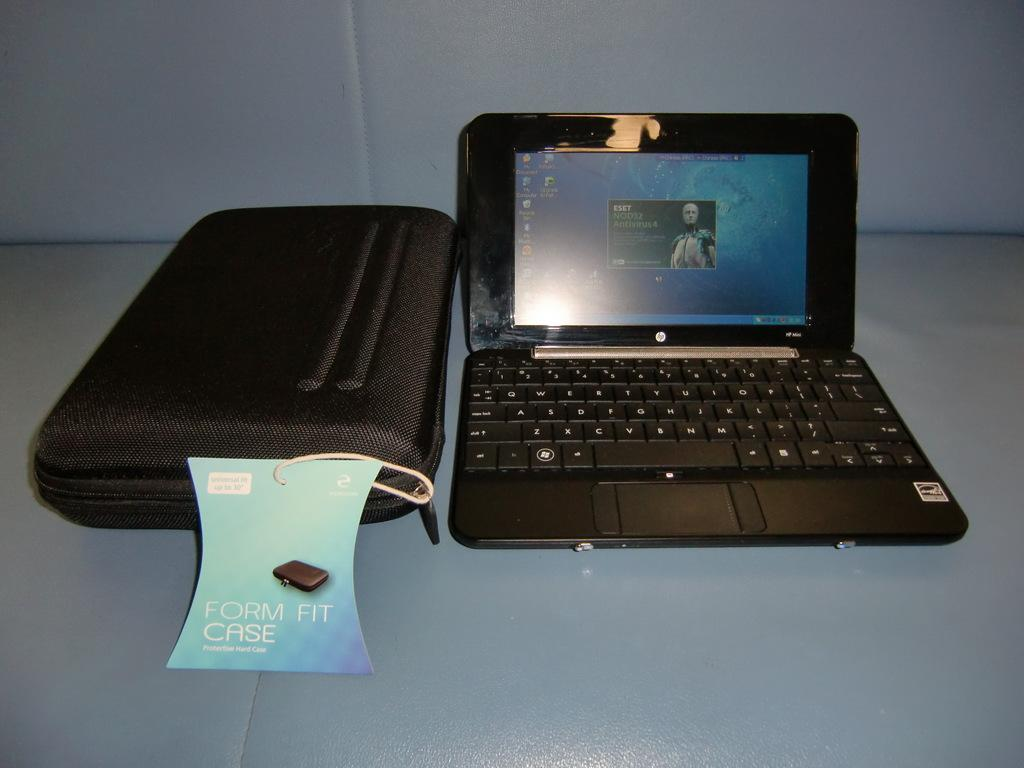What electronic device is visible in the image? There is a laptop in the image. What is placed next to the laptop? There is a case in the image. Where are the laptop and case located? Both the laptop and the case are placed on a surface. What type of tramp is visible in the image? There is no tramp present in the image. How does the society depicted in the image interact with the laptop and case? There is no society depicted in the image, as it only shows a laptop and a case placed on a surface. 